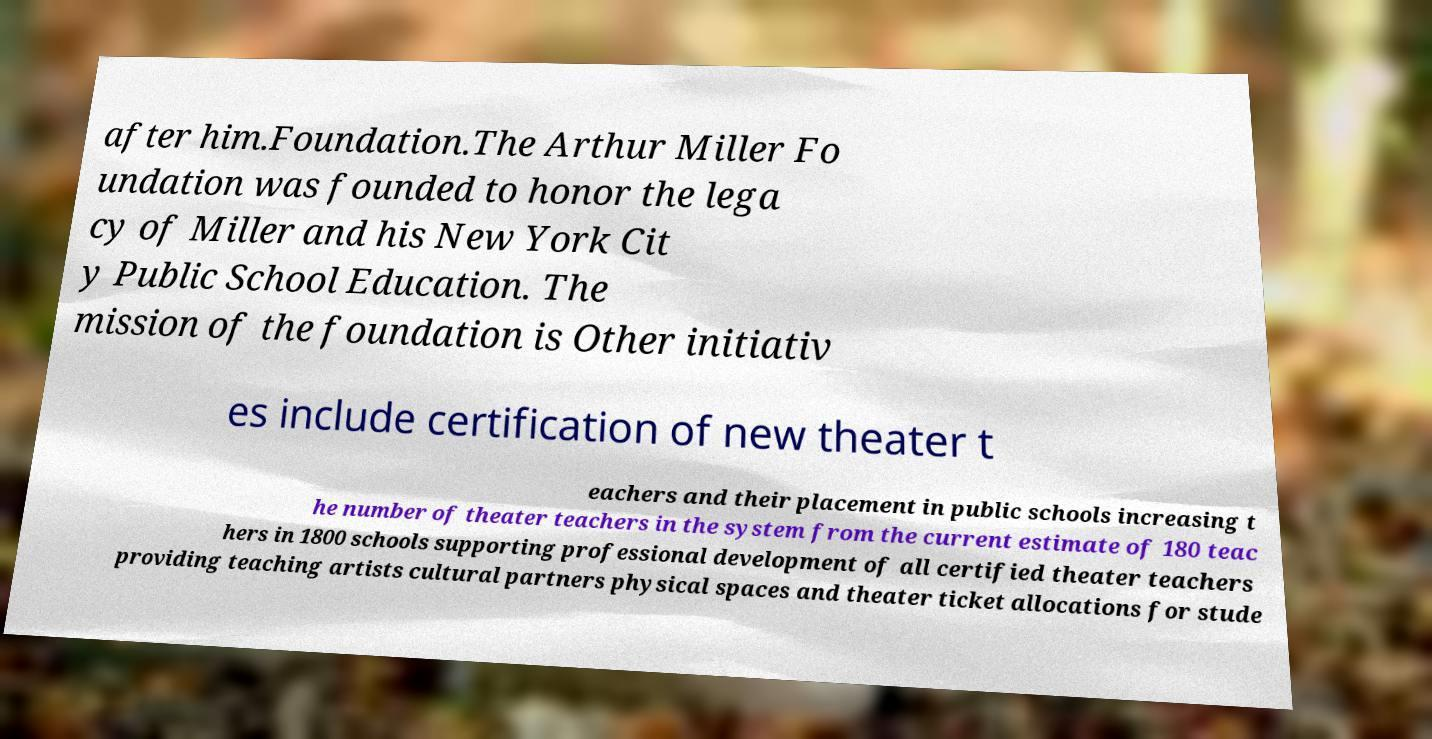Please read and relay the text visible in this image. What does it say? after him.Foundation.The Arthur Miller Fo undation was founded to honor the lega cy of Miller and his New York Cit y Public School Education. The mission of the foundation is Other initiativ es include certification of new theater t eachers and their placement in public schools increasing t he number of theater teachers in the system from the current estimate of 180 teac hers in 1800 schools supporting professional development of all certified theater teachers providing teaching artists cultural partners physical spaces and theater ticket allocations for stude 